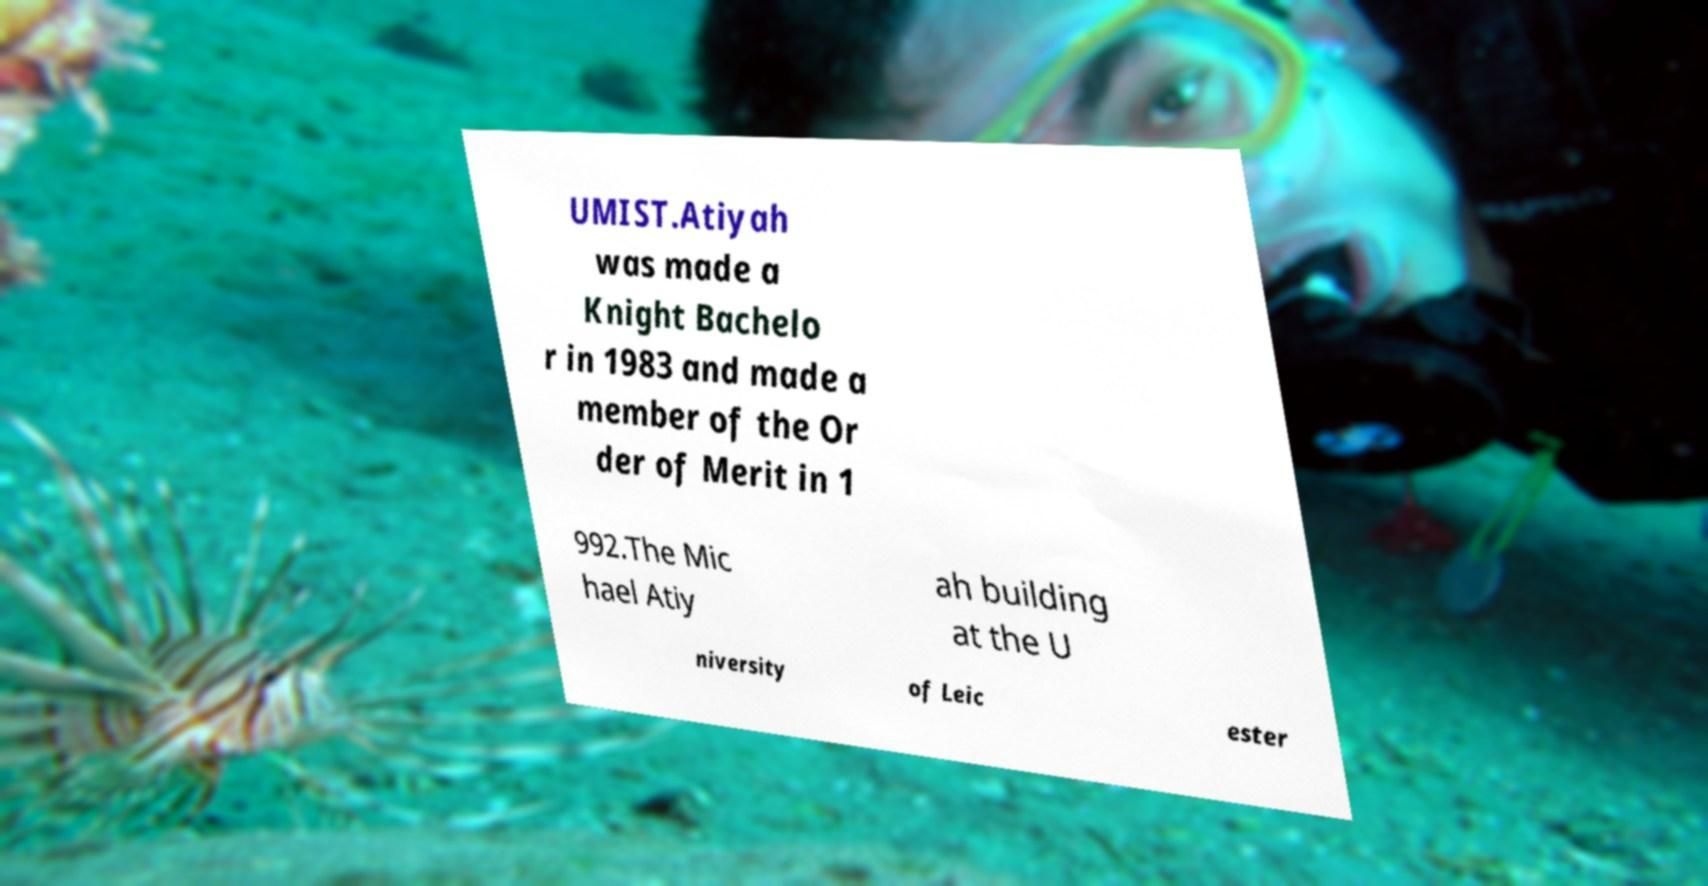Can you read and provide the text displayed in the image?This photo seems to have some interesting text. Can you extract and type it out for me? UMIST.Atiyah was made a Knight Bachelo r in 1983 and made a member of the Or der of Merit in 1 992.The Mic hael Atiy ah building at the U niversity of Leic ester 